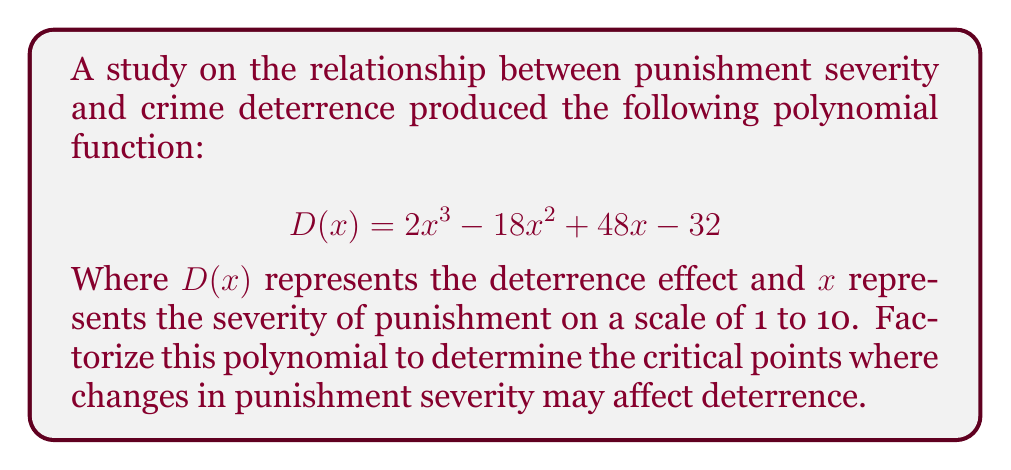Could you help me with this problem? To factorize this polynomial, we'll follow these steps:

1) First, let's check if there's a common factor:
   $2x^3 - 18x^2 + 48x - 32$
   There's no common factor for all terms.

2) Next, let's try the rational root theorem. Potential roots are factors of the constant term (32): ±1, ±2, ±4, ±8, ±16, ±32

3) Testing these values, we find that $x = 2$ is a root.

4) Divide the polynomial by $(x - 2)$:

   $$\frac{2x^3 - 18x^2 + 48x - 32}{x - 2} = 2x^2 - 14x + 20$$

5) The quadratic $2x^2 - 14x + 20$ can be factored further:

   $2x^2 - 14x + 20 = 2(x^2 - 7x + 10) = 2(x - 2)(x - 5)$

6) Combining all factors:

   $D(x) = 2x^3 - 18x^2 + 48x - 32 = 2(x - 2)^2(x - 5)$

This factorization reveals that the critical points for the deterrence effect occur at $x = 2$ and $x = 5$ on the punishment severity scale.
Answer: $D(x) = 2(x - 2)^2(x - 5)$ 